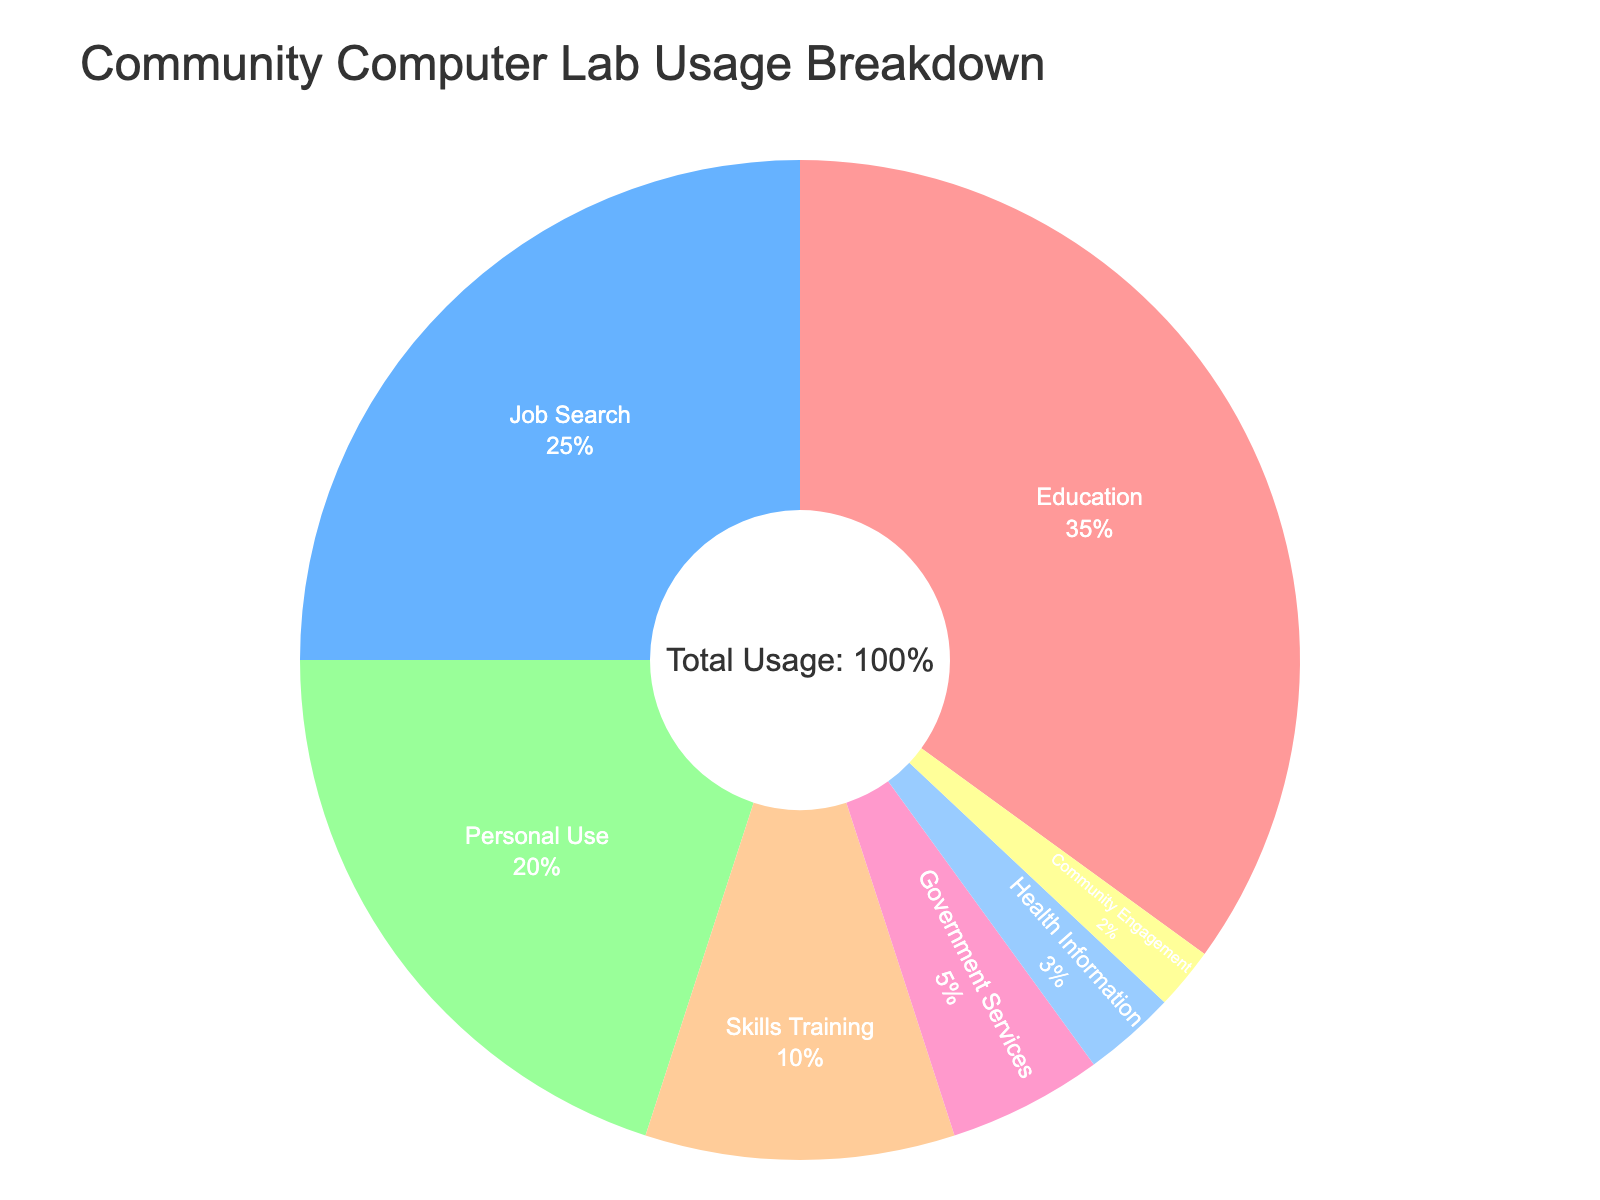Which purpose constitutes the largest portion of computer lab usage? The largest portion is determined by the highest percentage. Education has 35%, which is the highest among the categories.
Answer: Education What is the combined percentage of computer lab usage for Job Search and Skills Training? Add the percentages of Job Search and Skills Training: 25% + 10% = 35%.
Answer: 35% Which is used more, Job Search or Personal Use, and by how much? Job Search is 25% while Personal Use is 20%. The difference is 25% - 20% = 5%.
Answer: Job Search by 5% How do the percentages of Health Information and Community Engagement usage compare? Health Information is 3% and Community Engagement is 2%. Health Information is higher by 1%.
Answer: Health Information is higher by 1% What proportion of the computer lab usage is dedicated to non-education purposes? Subtract the percentage dedicated to Education from 100%: 100% - 35% = 65%.
Answer: 65% Is the usage for Government Services higher or lower than Skills Training? Government Services has 5% and Skills Training has 10%. Government Services is lower.
Answer: Lower How much more is computer lab usage for Education than for Health Information? Calculate the difference: 35% (Education) - 3% (Health Information) = 32%.
Answer: 32% Which purposes constitute less than 10% of the computer lab usage each? The purposes with less than 10% are Skills Training (10%), Government Services (5%), Health Information (3%), and Community Engagement (2%).
Answer: Skills Training, Government Services, Health Information, Community Engagement Is the percentage of Personal Use greater than or less than the sum of Health Information and Community Engagement? Sum the percentages of Health Information and Community Engagement: 3% + 2% = 5%. Personal Use is 20%, which is greater than 5%.
Answer: Greater What percentage of the computer lab usage is allocated to activities other than Education, Job Search, and Personal Use? Sum the other activities: 10% (Skills Training) + 5% (Government Services) + 3% (Health Information) + 2% (Community Engagement) = 20%.
Answer: 20% 